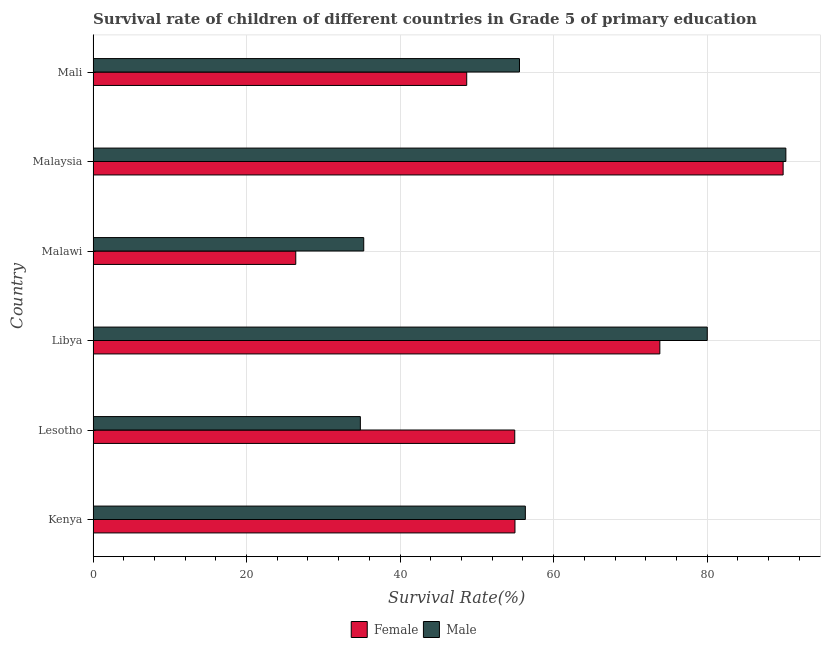How many groups of bars are there?
Offer a terse response. 6. How many bars are there on the 6th tick from the bottom?
Provide a succinct answer. 2. What is the label of the 3rd group of bars from the top?
Ensure brevity in your answer.  Malawi. In how many cases, is the number of bars for a given country not equal to the number of legend labels?
Make the answer very short. 0. What is the survival rate of female students in primary education in Malawi?
Provide a succinct answer. 26.41. Across all countries, what is the maximum survival rate of female students in primary education?
Give a very brief answer. 89.9. Across all countries, what is the minimum survival rate of male students in primary education?
Give a very brief answer. 34.82. In which country was the survival rate of female students in primary education maximum?
Offer a very short reply. Malaysia. In which country was the survival rate of female students in primary education minimum?
Your answer should be compact. Malawi. What is the total survival rate of male students in primary education in the graph?
Your response must be concise. 352.24. What is the difference between the survival rate of female students in primary education in Kenya and that in Mali?
Your answer should be compact. 6.29. What is the difference between the survival rate of female students in primary education in Malaysia and the survival rate of male students in primary education in Lesotho?
Your answer should be very brief. 55.08. What is the average survival rate of male students in primary education per country?
Provide a succinct answer. 58.71. What is the difference between the survival rate of female students in primary education and survival rate of male students in primary education in Lesotho?
Make the answer very short. 20.11. In how many countries, is the survival rate of male students in primary education greater than 80 %?
Provide a succinct answer. 2. What is the ratio of the survival rate of male students in primary education in Malawi to that in Mali?
Your answer should be very brief. 0.64. Is the survival rate of female students in primary education in Kenya less than that in Malaysia?
Provide a short and direct response. Yes. What is the difference between the highest and the second highest survival rate of male students in primary education?
Ensure brevity in your answer.  10.24. What is the difference between the highest and the lowest survival rate of male students in primary education?
Ensure brevity in your answer.  55.44. In how many countries, is the survival rate of female students in primary education greater than the average survival rate of female students in primary education taken over all countries?
Offer a terse response. 2. How many bars are there?
Make the answer very short. 12. How many countries are there in the graph?
Keep it short and to the point. 6. Are the values on the major ticks of X-axis written in scientific E-notation?
Make the answer very short. No. Does the graph contain any zero values?
Offer a very short reply. No. Where does the legend appear in the graph?
Offer a terse response. Bottom center. What is the title of the graph?
Your answer should be compact. Survival rate of children of different countries in Grade 5 of primary education. Does "Foreign liabilities" appear as one of the legend labels in the graph?
Offer a terse response. No. What is the label or title of the X-axis?
Your answer should be compact. Survival Rate(%). What is the Survival Rate(%) of Female in Kenya?
Give a very brief answer. 54.97. What is the Survival Rate(%) of Male in Kenya?
Your response must be concise. 56.32. What is the Survival Rate(%) in Female in Lesotho?
Offer a terse response. 54.94. What is the Survival Rate(%) in Male in Lesotho?
Make the answer very short. 34.82. What is the Survival Rate(%) of Female in Libya?
Offer a very short reply. 73.84. What is the Survival Rate(%) of Male in Libya?
Your response must be concise. 80.02. What is the Survival Rate(%) in Female in Malawi?
Offer a very short reply. 26.41. What is the Survival Rate(%) of Male in Malawi?
Provide a short and direct response. 35.26. What is the Survival Rate(%) in Female in Malaysia?
Offer a very short reply. 89.9. What is the Survival Rate(%) of Male in Malaysia?
Offer a terse response. 90.26. What is the Survival Rate(%) of Female in Mali?
Provide a succinct answer. 48.68. What is the Survival Rate(%) of Male in Mali?
Your answer should be compact. 55.55. Across all countries, what is the maximum Survival Rate(%) in Female?
Your response must be concise. 89.9. Across all countries, what is the maximum Survival Rate(%) in Male?
Your answer should be compact. 90.26. Across all countries, what is the minimum Survival Rate(%) in Female?
Ensure brevity in your answer.  26.41. Across all countries, what is the minimum Survival Rate(%) in Male?
Provide a succinct answer. 34.82. What is the total Survival Rate(%) of Female in the graph?
Make the answer very short. 348.74. What is the total Survival Rate(%) in Male in the graph?
Give a very brief answer. 352.24. What is the difference between the Survival Rate(%) of Female in Kenya and that in Lesotho?
Your answer should be very brief. 0.03. What is the difference between the Survival Rate(%) of Male in Kenya and that in Lesotho?
Provide a succinct answer. 21.5. What is the difference between the Survival Rate(%) in Female in Kenya and that in Libya?
Your answer should be compact. -18.87. What is the difference between the Survival Rate(%) of Male in Kenya and that in Libya?
Make the answer very short. -23.7. What is the difference between the Survival Rate(%) of Female in Kenya and that in Malawi?
Provide a short and direct response. 28.56. What is the difference between the Survival Rate(%) in Male in Kenya and that in Malawi?
Ensure brevity in your answer.  21.06. What is the difference between the Survival Rate(%) of Female in Kenya and that in Malaysia?
Offer a very short reply. -34.94. What is the difference between the Survival Rate(%) in Male in Kenya and that in Malaysia?
Keep it short and to the point. -33.94. What is the difference between the Survival Rate(%) of Female in Kenya and that in Mali?
Provide a succinct answer. 6.29. What is the difference between the Survival Rate(%) in Male in Kenya and that in Mali?
Offer a terse response. 0.76. What is the difference between the Survival Rate(%) of Female in Lesotho and that in Libya?
Your answer should be very brief. -18.9. What is the difference between the Survival Rate(%) in Male in Lesotho and that in Libya?
Provide a succinct answer. -45.2. What is the difference between the Survival Rate(%) in Female in Lesotho and that in Malawi?
Offer a very short reply. 28.53. What is the difference between the Survival Rate(%) of Male in Lesotho and that in Malawi?
Your answer should be very brief. -0.44. What is the difference between the Survival Rate(%) in Female in Lesotho and that in Malaysia?
Ensure brevity in your answer.  -34.97. What is the difference between the Survival Rate(%) in Male in Lesotho and that in Malaysia?
Ensure brevity in your answer.  -55.44. What is the difference between the Survival Rate(%) in Female in Lesotho and that in Mali?
Keep it short and to the point. 6.26. What is the difference between the Survival Rate(%) in Male in Lesotho and that in Mali?
Your response must be concise. -20.73. What is the difference between the Survival Rate(%) of Female in Libya and that in Malawi?
Make the answer very short. 47.43. What is the difference between the Survival Rate(%) in Male in Libya and that in Malawi?
Your answer should be compact. 44.76. What is the difference between the Survival Rate(%) in Female in Libya and that in Malaysia?
Make the answer very short. -16.06. What is the difference between the Survival Rate(%) in Male in Libya and that in Malaysia?
Provide a short and direct response. -10.24. What is the difference between the Survival Rate(%) in Female in Libya and that in Mali?
Make the answer very short. 25.16. What is the difference between the Survival Rate(%) of Male in Libya and that in Mali?
Provide a succinct answer. 24.47. What is the difference between the Survival Rate(%) in Female in Malawi and that in Malaysia?
Ensure brevity in your answer.  -63.5. What is the difference between the Survival Rate(%) in Male in Malawi and that in Malaysia?
Your answer should be compact. -55. What is the difference between the Survival Rate(%) of Female in Malawi and that in Mali?
Your answer should be very brief. -22.27. What is the difference between the Survival Rate(%) of Male in Malawi and that in Mali?
Your answer should be compact. -20.29. What is the difference between the Survival Rate(%) in Female in Malaysia and that in Mali?
Your response must be concise. 41.22. What is the difference between the Survival Rate(%) of Male in Malaysia and that in Mali?
Make the answer very short. 34.7. What is the difference between the Survival Rate(%) in Female in Kenya and the Survival Rate(%) in Male in Lesotho?
Provide a succinct answer. 20.14. What is the difference between the Survival Rate(%) in Female in Kenya and the Survival Rate(%) in Male in Libya?
Make the answer very short. -25.05. What is the difference between the Survival Rate(%) in Female in Kenya and the Survival Rate(%) in Male in Malawi?
Give a very brief answer. 19.71. What is the difference between the Survival Rate(%) in Female in Kenya and the Survival Rate(%) in Male in Malaysia?
Your response must be concise. -35.29. What is the difference between the Survival Rate(%) in Female in Kenya and the Survival Rate(%) in Male in Mali?
Keep it short and to the point. -0.59. What is the difference between the Survival Rate(%) in Female in Lesotho and the Survival Rate(%) in Male in Libya?
Your response must be concise. -25.08. What is the difference between the Survival Rate(%) in Female in Lesotho and the Survival Rate(%) in Male in Malawi?
Make the answer very short. 19.68. What is the difference between the Survival Rate(%) in Female in Lesotho and the Survival Rate(%) in Male in Malaysia?
Your response must be concise. -35.32. What is the difference between the Survival Rate(%) in Female in Lesotho and the Survival Rate(%) in Male in Mali?
Your answer should be compact. -0.62. What is the difference between the Survival Rate(%) in Female in Libya and the Survival Rate(%) in Male in Malawi?
Ensure brevity in your answer.  38.58. What is the difference between the Survival Rate(%) of Female in Libya and the Survival Rate(%) of Male in Malaysia?
Provide a short and direct response. -16.42. What is the difference between the Survival Rate(%) of Female in Libya and the Survival Rate(%) of Male in Mali?
Offer a terse response. 18.29. What is the difference between the Survival Rate(%) in Female in Malawi and the Survival Rate(%) in Male in Malaysia?
Make the answer very short. -63.85. What is the difference between the Survival Rate(%) of Female in Malawi and the Survival Rate(%) of Male in Mali?
Your answer should be very brief. -29.15. What is the difference between the Survival Rate(%) of Female in Malaysia and the Survival Rate(%) of Male in Mali?
Keep it short and to the point. 34.35. What is the average Survival Rate(%) of Female per country?
Your answer should be very brief. 58.12. What is the average Survival Rate(%) of Male per country?
Offer a very short reply. 58.71. What is the difference between the Survival Rate(%) in Female and Survival Rate(%) in Male in Kenya?
Offer a terse response. -1.35. What is the difference between the Survival Rate(%) in Female and Survival Rate(%) in Male in Lesotho?
Provide a succinct answer. 20.11. What is the difference between the Survival Rate(%) in Female and Survival Rate(%) in Male in Libya?
Your response must be concise. -6.18. What is the difference between the Survival Rate(%) in Female and Survival Rate(%) in Male in Malawi?
Your answer should be very brief. -8.86. What is the difference between the Survival Rate(%) in Female and Survival Rate(%) in Male in Malaysia?
Make the answer very short. -0.36. What is the difference between the Survival Rate(%) in Female and Survival Rate(%) in Male in Mali?
Offer a terse response. -6.88. What is the ratio of the Survival Rate(%) in Female in Kenya to that in Lesotho?
Provide a short and direct response. 1. What is the ratio of the Survival Rate(%) of Male in Kenya to that in Lesotho?
Offer a very short reply. 1.62. What is the ratio of the Survival Rate(%) of Female in Kenya to that in Libya?
Offer a terse response. 0.74. What is the ratio of the Survival Rate(%) in Male in Kenya to that in Libya?
Make the answer very short. 0.7. What is the ratio of the Survival Rate(%) in Female in Kenya to that in Malawi?
Give a very brief answer. 2.08. What is the ratio of the Survival Rate(%) in Male in Kenya to that in Malawi?
Keep it short and to the point. 1.6. What is the ratio of the Survival Rate(%) in Female in Kenya to that in Malaysia?
Your answer should be compact. 0.61. What is the ratio of the Survival Rate(%) in Male in Kenya to that in Malaysia?
Make the answer very short. 0.62. What is the ratio of the Survival Rate(%) of Female in Kenya to that in Mali?
Ensure brevity in your answer.  1.13. What is the ratio of the Survival Rate(%) of Male in Kenya to that in Mali?
Ensure brevity in your answer.  1.01. What is the ratio of the Survival Rate(%) in Female in Lesotho to that in Libya?
Your answer should be very brief. 0.74. What is the ratio of the Survival Rate(%) in Male in Lesotho to that in Libya?
Your answer should be compact. 0.44. What is the ratio of the Survival Rate(%) of Female in Lesotho to that in Malawi?
Ensure brevity in your answer.  2.08. What is the ratio of the Survival Rate(%) of Male in Lesotho to that in Malawi?
Offer a terse response. 0.99. What is the ratio of the Survival Rate(%) of Female in Lesotho to that in Malaysia?
Provide a short and direct response. 0.61. What is the ratio of the Survival Rate(%) in Male in Lesotho to that in Malaysia?
Your response must be concise. 0.39. What is the ratio of the Survival Rate(%) in Female in Lesotho to that in Mali?
Offer a very short reply. 1.13. What is the ratio of the Survival Rate(%) of Male in Lesotho to that in Mali?
Give a very brief answer. 0.63. What is the ratio of the Survival Rate(%) in Female in Libya to that in Malawi?
Provide a succinct answer. 2.8. What is the ratio of the Survival Rate(%) in Male in Libya to that in Malawi?
Ensure brevity in your answer.  2.27. What is the ratio of the Survival Rate(%) of Female in Libya to that in Malaysia?
Offer a very short reply. 0.82. What is the ratio of the Survival Rate(%) in Male in Libya to that in Malaysia?
Your answer should be compact. 0.89. What is the ratio of the Survival Rate(%) in Female in Libya to that in Mali?
Your answer should be very brief. 1.52. What is the ratio of the Survival Rate(%) of Male in Libya to that in Mali?
Provide a succinct answer. 1.44. What is the ratio of the Survival Rate(%) in Female in Malawi to that in Malaysia?
Your answer should be compact. 0.29. What is the ratio of the Survival Rate(%) in Male in Malawi to that in Malaysia?
Ensure brevity in your answer.  0.39. What is the ratio of the Survival Rate(%) of Female in Malawi to that in Mali?
Give a very brief answer. 0.54. What is the ratio of the Survival Rate(%) in Male in Malawi to that in Mali?
Your answer should be compact. 0.63. What is the ratio of the Survival Rate(%) of Female in Malaysia to that in Mali?
Your answer should be compact. 1.85. What is the ratio of the Survival Rate(%) in Male in Malaysia to that in Mali?
Your response must be concise. 1.62. What is the difference between the highest and the second highest Survival Rate(%) of Female?
Provide a succinct answer. 16.06. What is the difference between the highest and the second highest Survival Rate(%) of Male?
Offer a very short reply. 10.24. What is the difference between the highest and the lowest Survival Rate(%) of Female?
Keep it short and to the point. 63.5. What is the difference between the highest and the lowest Survival Rate(%) of Male?
Provide a succinct answer. 55.44. 